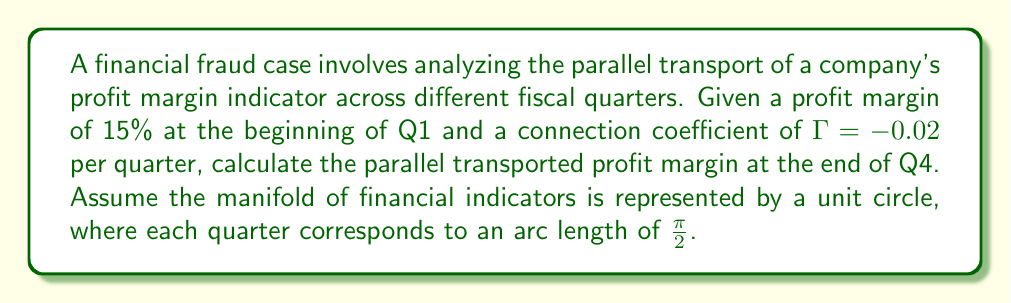Could you help me with this problem? To solve this problem, we'll use the concept of parallel transport in differential geometry applied to financial indicators:

1) First, we need to understand that parallel transport on a circle is governed by the equation:

   $$\frac{dv}{dt} + \Gamma v = 0$$

   where $v$ is the transported value and $\Gamma$ is the connection coefficient.

2) The solution to this differential equation is:

   $$v(t) = v_0 e^{-\Gamma t}$$

   where $v_0$ is the initial value and $t$ is the parameter along the curve.

3) In our case:
   - $v_0 = 15\%$ (initial profit margin)
   - $\Gamma = -0.02$ per quarter
   - $t = 4$ quarters (from Q1 to Q4)

4) Substituting these values:

   $$v(4) = 15\% \cdot e^{-(-0.02) \cdot 4}$$

5) Simplifying:

   $$v(4) = 15\% \cdot e^{0.08} \approx 16.24\%$$

Thus, the parallel transported profit margin at the end of Q4 is approximately 16.24%.
Answer: 16.24% 